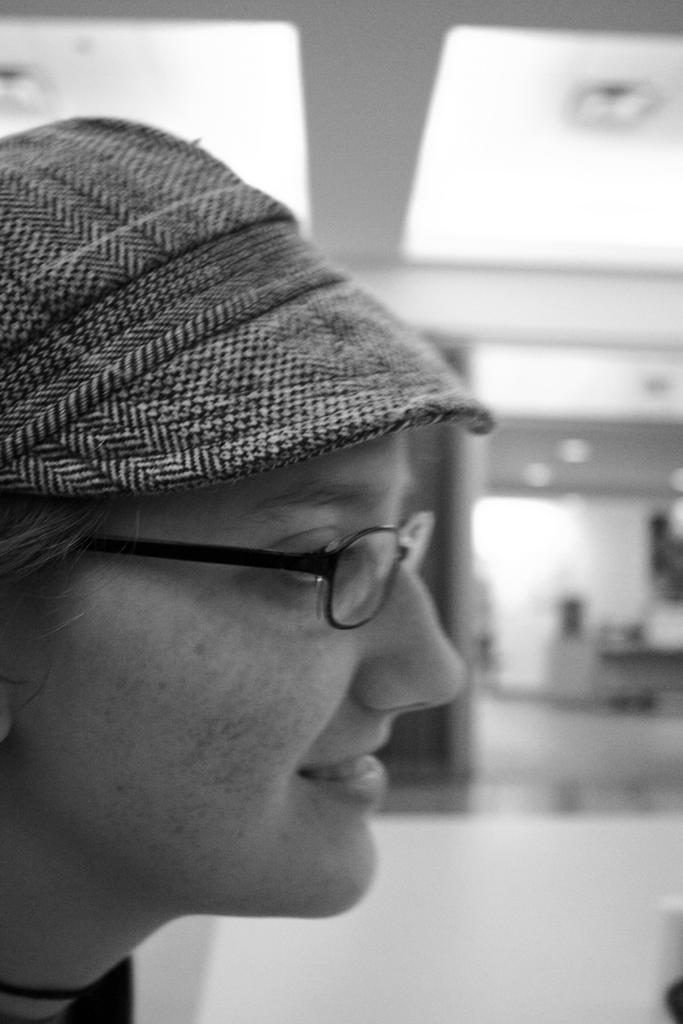Who is present in the image? There is a woman in the image. What is the woman wearing on her head? The woman is wearing a cap. Are there any accessories visible on the woman's face? Yes, the woman is wearing spectacles on the left side. What type of structure can be seen in the image? There is a roof visible in the image. What surface is visible on the right side of the image? There is a floor visible on the right side of the image. How many sheep are present in the image? There are no sheep present in the image. What time of day is indicated by the hour on the clock in the image? There is no clock visible in the image, so we cannot determine the time of day. 